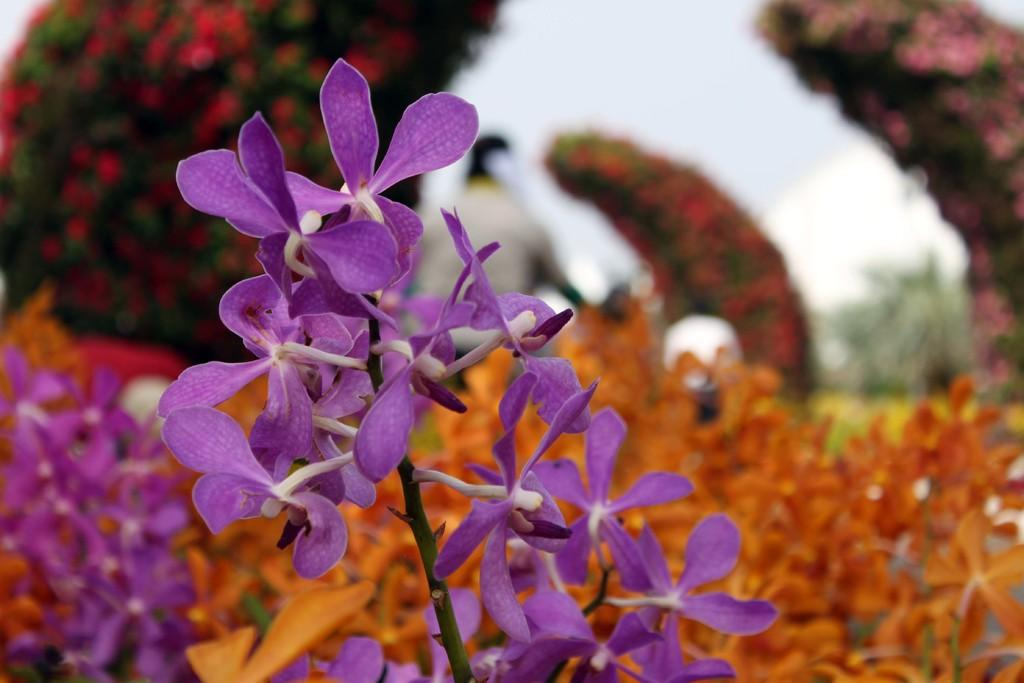What type of plants are present in the image? There are plants with flowers in the image. What structure can be seen in the image, made of flowers? There is a flower arch visible in the image. Can you describe the person in the image? Unfortunately, the facts provided do not mention any details about the person in the image. What type of work is the tank performing in the image? There is no tank present in the image, so it is not possible to answer that question. 